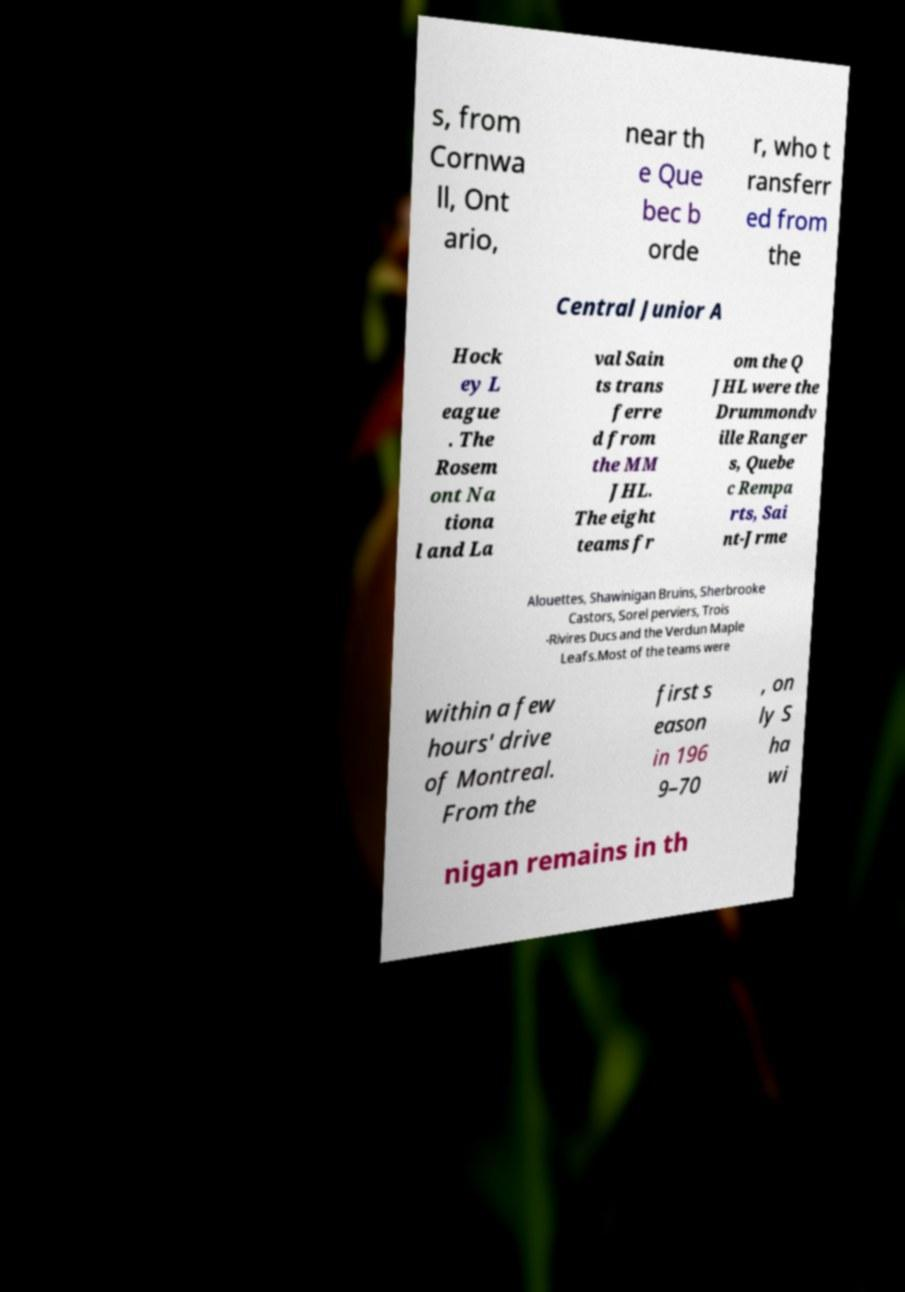There's text embedded in this image that I need extracted. Can you transcribe it verbatim? s, from Cornwa ll, Ont ario, near th e Que bec b orde r, who t ransferr ed from the Central Junior A Hock ey L eague . The Rosem ont Na tiona l and La val Sain ts trans ferre d from the MM JHL. The eight teams fr om the Q JHL were the Drummondv ille Ranger s, Quebe c Rempa rts, Sai nt-Jrme Alouettes, Shawinigan Bruins, Sherbrooke Castors, Sorel perviers, Trois -Rivires Ducs and the Verdun Maple Leafs.Most of the teams were within a few hours' drive of Montreal. From the first s eason in 196 9–70 , on ly S ha wi nigan remains in th 